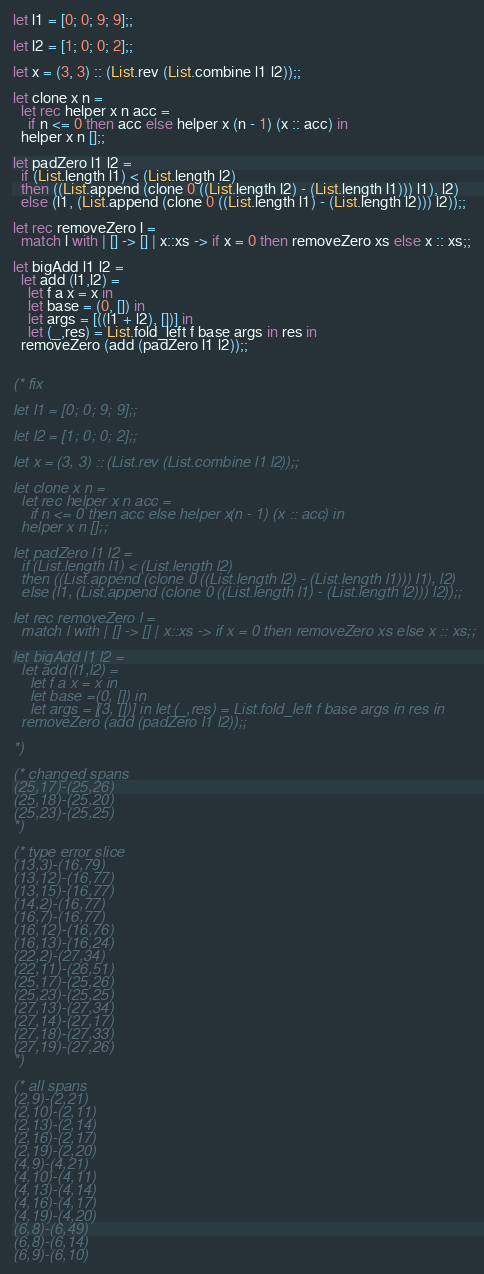<code> <loc_0><loc_0><loc_500><loc_500><_OCaml_>
let l1 = [0; 0; 9; 9];;

let l2 = [1; 0; 0; 2];;

let x = (3, 3) :: (List.rev (List.combine l1 l2));;

let clone x n =
  let rec helper x n acc =
    if n <= 0 then acc else helper x (n - 1) (x :: acc) in
  helper x n [];;

let padZero l1 l2 =
  if (List.length l1) < (List.length l2)
  then ((List.append (clone 0 ((List.length l2) - (List.length l1))) l1), l2)
  else (l1, (List.append (clone 0 ((List.length l1) - (List.length l2))) l2));;

let rec removeZero l =
  match l with | [] -> [] | x::xs -> if x = 0 then removeZero xs else x :: xs;;

let bigAdd l1 l2 =
  let add (l1,l2) =
    let f a x = x in
    let base = (0, []) in
    let args = [((l1 + l2), [])] in
    let (_,res) = List.fold_left f base args in res in
  removeZero (add (padZero l1 l2));;


(* fix

let l1 = [0; 0; 9; 9];;

let l2 = [1; 0; 0; 2];;

let x = (3, 3) :: (List.rev (List.combine l1 l2));;

let clone x n =
  let rec helper x n acc =
    if n <= 0 then acc else helper x (n - 1) (x :: acc) in
  helper x n [];;

let padZero l1 l2 =
  if (List.length l1) < (List.length l2)
  then ((List.append (clone 0 ((List.length l2) - (List.length l1))) l1), l2)
  else (l1, (List.append (clone 0 ((List.length l1) - (List.length l2))) l2));;

let rec removeZero l =
  match l with | [] -> [] | x::xs -> if x = 0 then removeZero xs else x :: xs;;

let bigAdd l1 l2 =
  let add (l1,l2) =
    let f a x = x in
    let base = (0, []) in
    let args = [(3, [])] in let (_,res) = List.fold_left f base args in res in
  removeZero (add (padZero l1 l2));;

*)

(* changed spans
(25,17)-(25,26)
(25,18)-(25,20)
(25,23)-(25,25)
*)

(* type error slice
(13,3)-(16,79)
(13,12)-(16,77)
(13,15)-(16,77)
(14,2)-(16,77)
(16,7)-(16,77)
(16,12)-(16,76)
(16,13)-(16,24)
(22,2)-(27,34)
(22,11)-(26,51)
(25,17)-(25,26)
(25,23)-(25,25)
(27,13)-(27,34)
(27,14)-(27,17)
(27,18)-(27,33)
(27,19)-(27,26)
*)

(* all spans
(2,9)-(2,21)
(2,10)-(2,11)
(2,13)-(2,14)
(2,16)-(2,17)
(2,19)-(2,20)
(4,9)-(4,21)
(4,10)-(4,11)
(4,13)-(4,14)
(4,16)-(4,17)
(4,19)-(4,20)
(6,8)-(6,49)
(6,8)-(6,14)
(6,9)-(6,10)</code> 